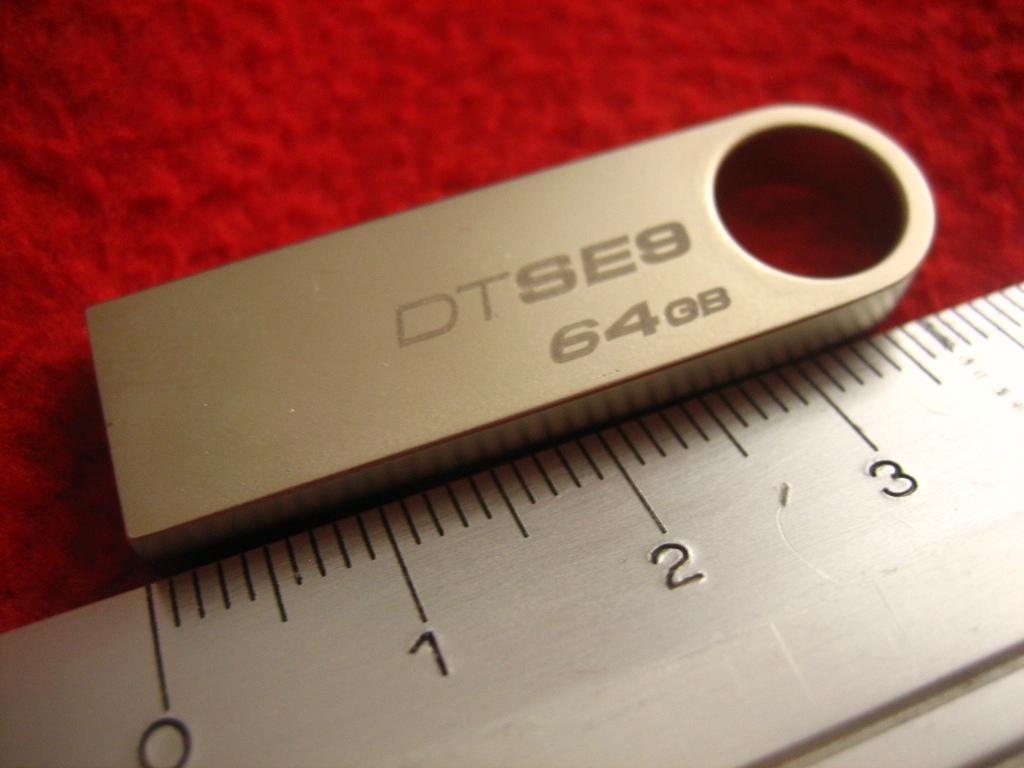How many gb is there?
Provide a succinct answer. 64. What is the brand?
Offer a very short reply. Dtse9. 